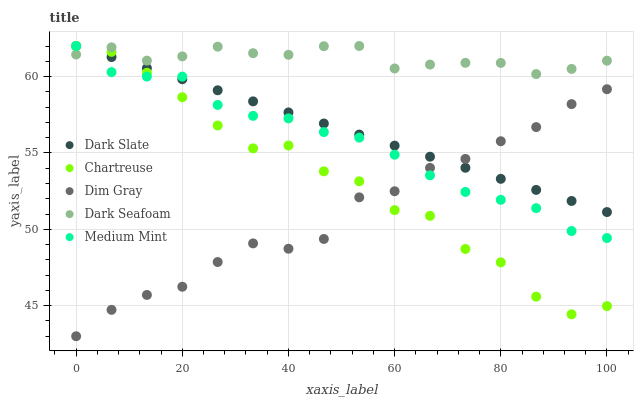Does Dim Gray have the minimum area under the curve?
Answer yes or no. Yes. Does Dark Seafoam have the maximum area under the curve?
Answer yes or no. Yes. Does Dark Slate have the minimum area under the curve?
Answer yes or no. No. Does Dark Slate have the maximum area under the curve?
Answer yes or no. No. Is Dark Slate the smoothest?
Answer yes or no. Yes. Is Chartreuse the roughest?
Answer yes or no. Yes. Is Chartreuse the smoothest?
Answer yes or no. No. Is Dark Slate the roughest?
Answer yes or no. No. Does Dim Gray have the lowest value?
Answer yes or no. Yes. Does Dark Slate have the lowest value?
Answer yes or no. No. Does Dark Seafoam have the highest value?
Answer yes or no. Yes. Does Dim Gray have the highest value?
Answer yes or no. No. Is Dim Gray less than Dark Seafoam?
Answer yes or no. Yes. Is Dark Seafoam greater than Dim Gray?
Answer yes or no. Yes. Does Medium Mint intersect Chartreuse?
Answer yes or no. Yes. Is Medium Mint less than Chartreuse?
Answer yes or no. No. Is Medium Mint greater than Chartreuse?
Answer yes or no. No. Does Dim Gray intersect Dark Seafoam?
Answer yes or no. No. 